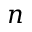<formula> <loc_0><loc_0><loc_500><loc_500>n</formula> 